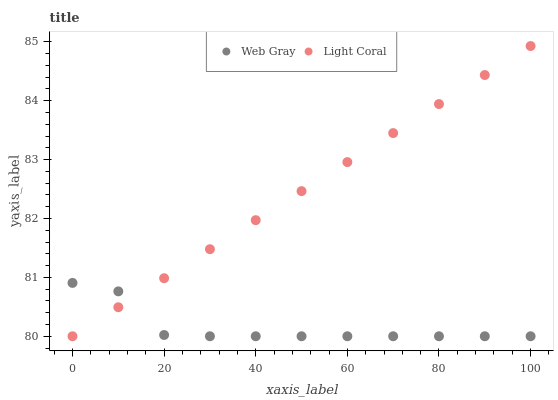Does Web Gray have the minimum area under the curve?
Answer yes or no. Yes. Does Light Coral have the maximum area under the curve?
Answer yes or no. Yes. Does Web Gray have the maximum area under the curve?
Answer yes or no. No. Is Light Coral the smoothest?
Answer yes or no. Yes. Is Web Gray the roughest?
Answer yes or no. Yes. Is Web Gray the smoothest?
Answer yes or no. No. Does Light Coral have the lowest value?
Answer yes or no. Yes. Does Light Coral have the highest value?
Answer yes or no. Yes. Does Web Gray have the highest value?
Answer yes or no. No. Does Light Coral intersect Web Gray?
Answer yes or no. Yes. Is Light Coral less than Web Gray?
Answer yes or no. No. Is Light Coral greater than Web Gray?
Answer yes or no. No. 